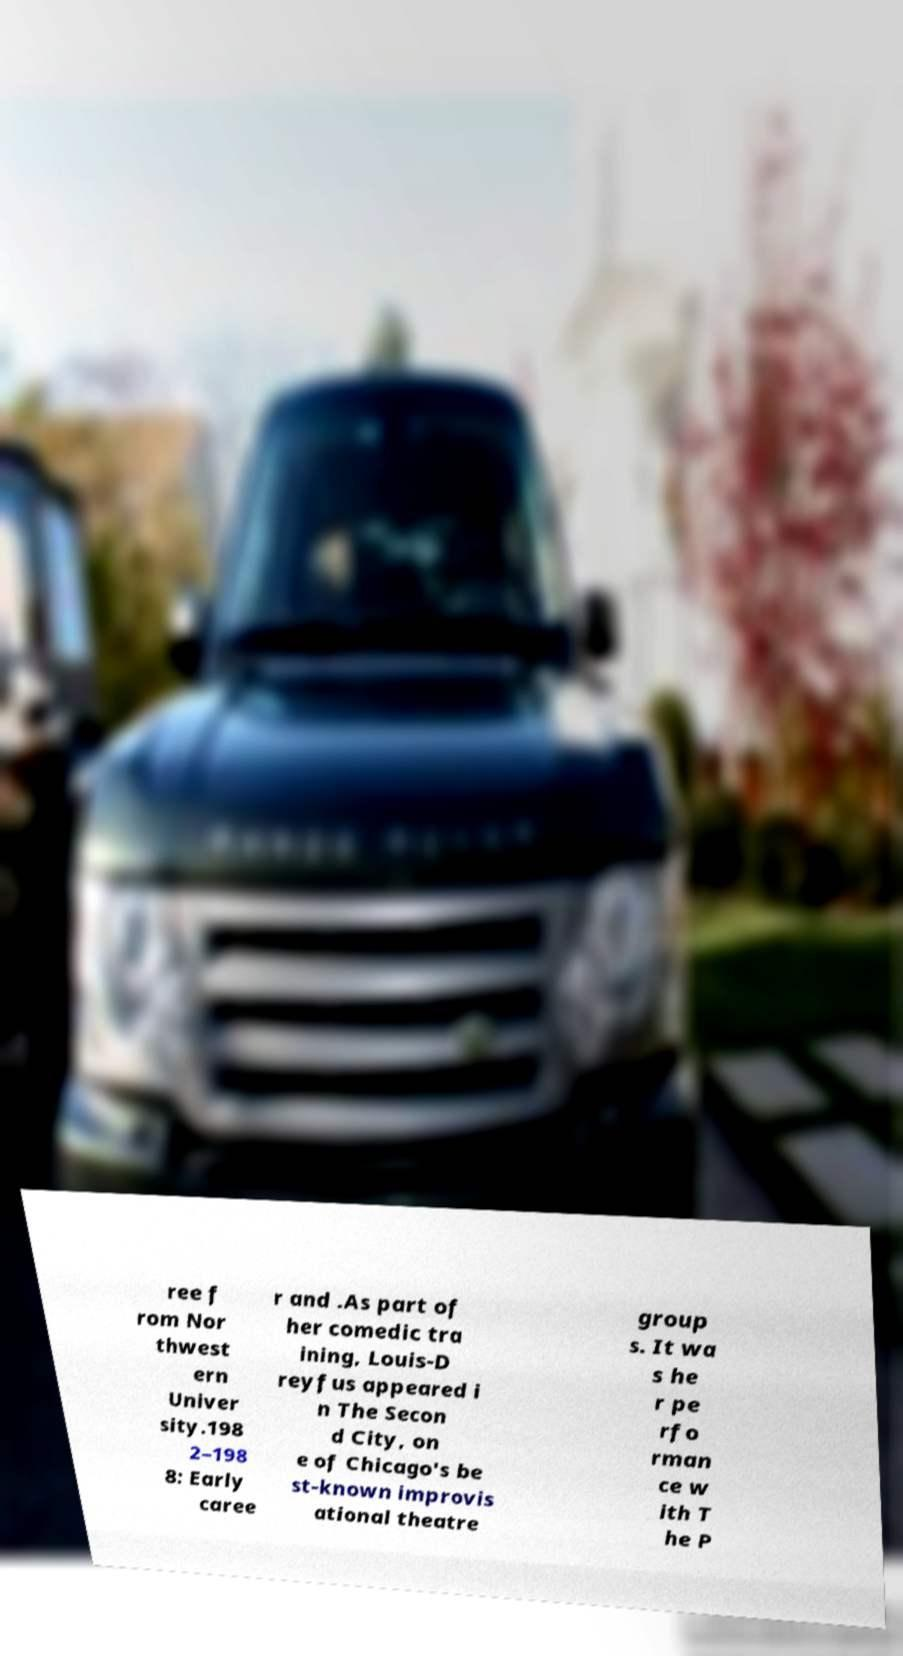Could you assist in decoding the text presented in this image and type it out clearly? ree f rom Nor thwest ern Univer sity.198 2–198 8: Early caree r and .As part of her comedic tra ining, Louis-D reyfus appeared i n The Secon d City, on e of Chicago's be st-known improvis ational theatre group s. It wa s he r pe rfo rman ce w ith T he P 